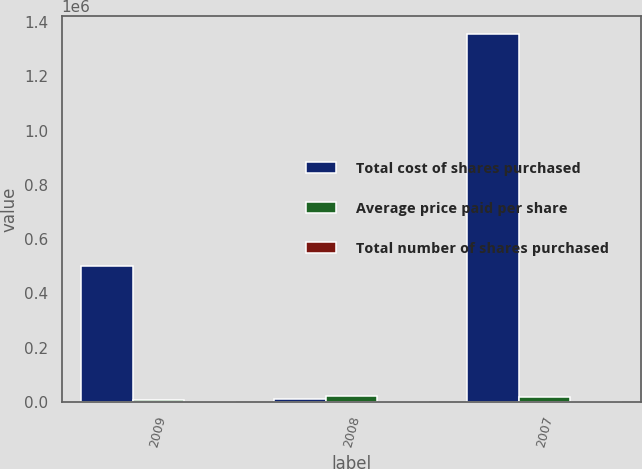Convert chart. <chart><loc_0><loc_0><loc_500><loc_500><stacked_bar_chart><ecel><fcel>2009<fcel>2008<fcel>2007<nl><fcel>Total cost of shares purchased<fcel>500097<fcel>12080.5<fcel>1.355e+06<nl><fcel>Average price paid per share<fcel>7825<fcel>21064.7<fcel>16336.1<nl><fcel>Total number of shares purchased<fcel>63.91<fcel>86.35<fcel>82.95<nl></chart> 